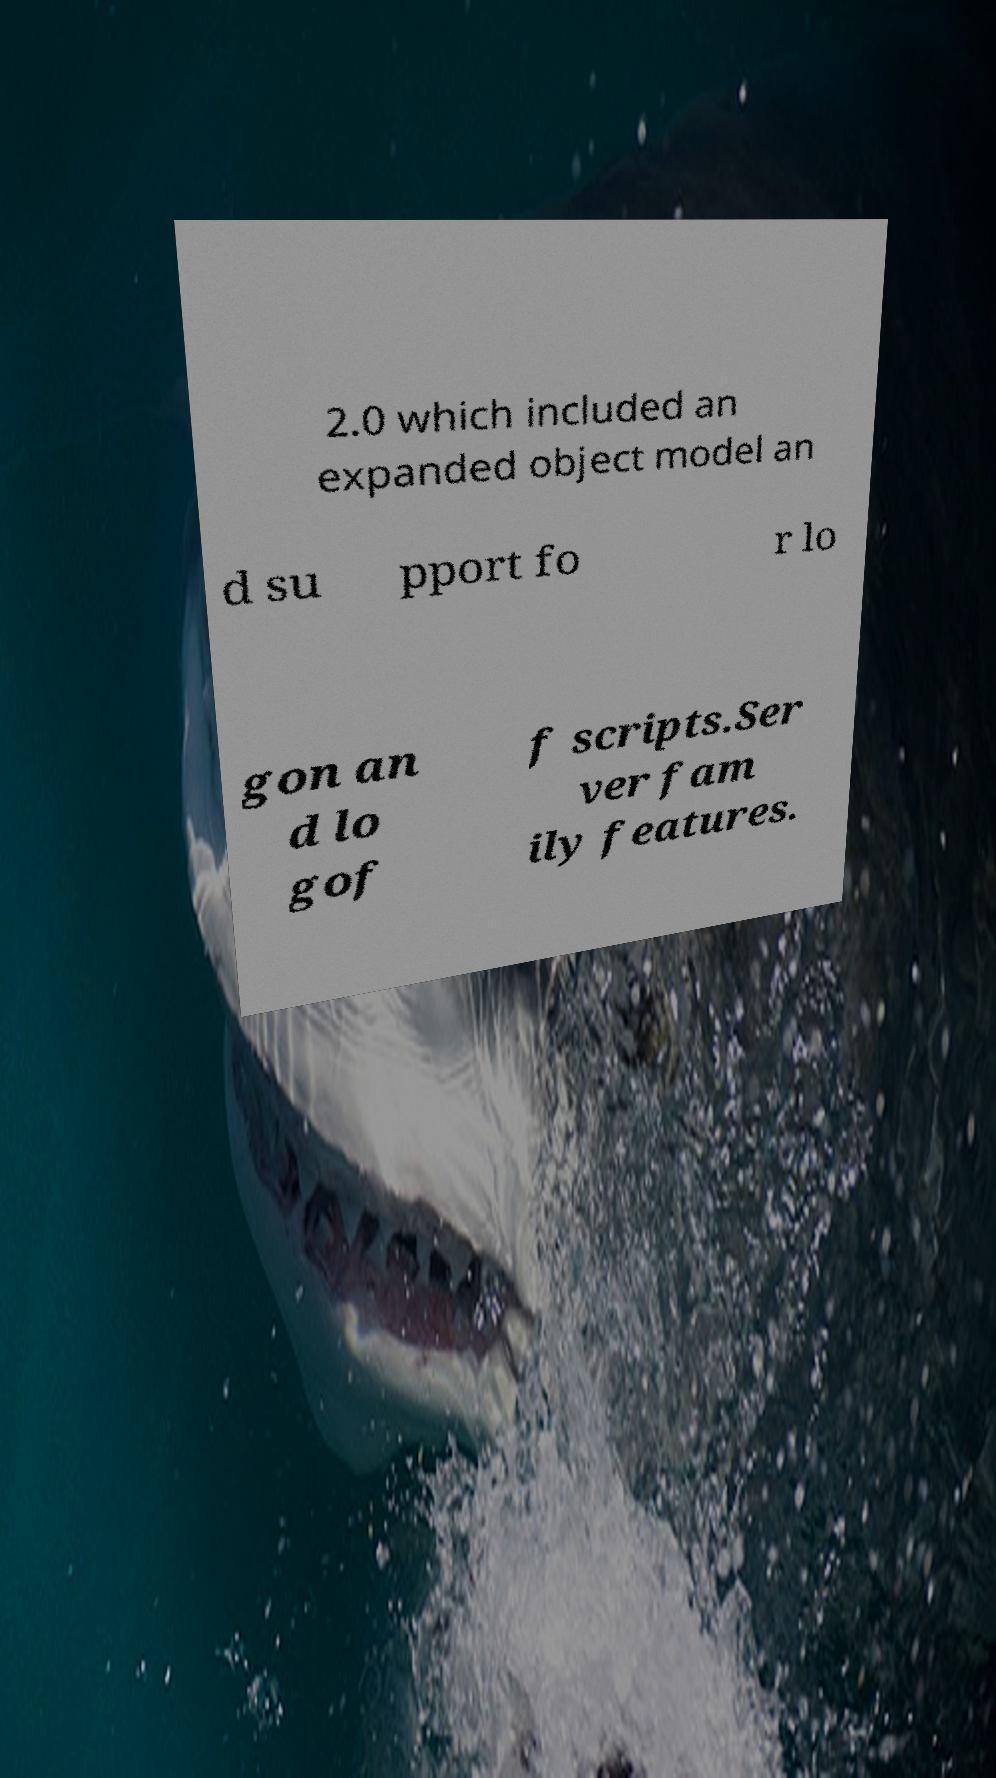Can you read and provide the text displayed in the image?This photo seems to have some interesting text. Can you extract and type it out for me? 2.0 which included an expanded object model an d su pport fo r lo gon an d lo gof f scripts.Ser ver fam ily features. 